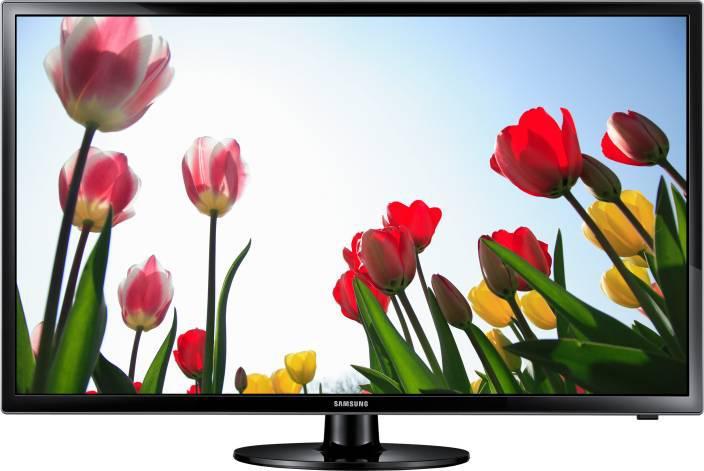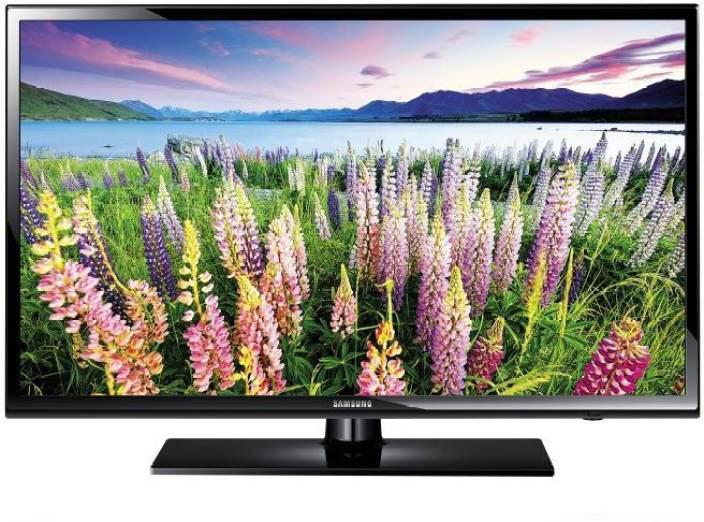The first image is the image on the left, the second image is the image on the right. Given the left and right images, does the statement "Both monitors have one leg." hold true? Answer yes or no. Yes. 